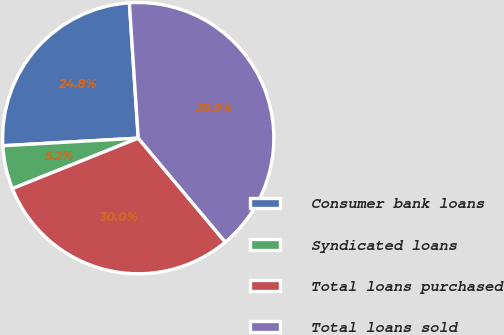<chart> <loc_0><loc_0><loc_500><loc_500><pie_chart><fcel>Consumer bank loans<fcel>Syndicated loans<fcel>Total loans purchased<fcel>Total loans sold<nl><fcel>24.85%<fcel>5.18%<fcel>30.03%<fcel>39.95%<nl></chart> 